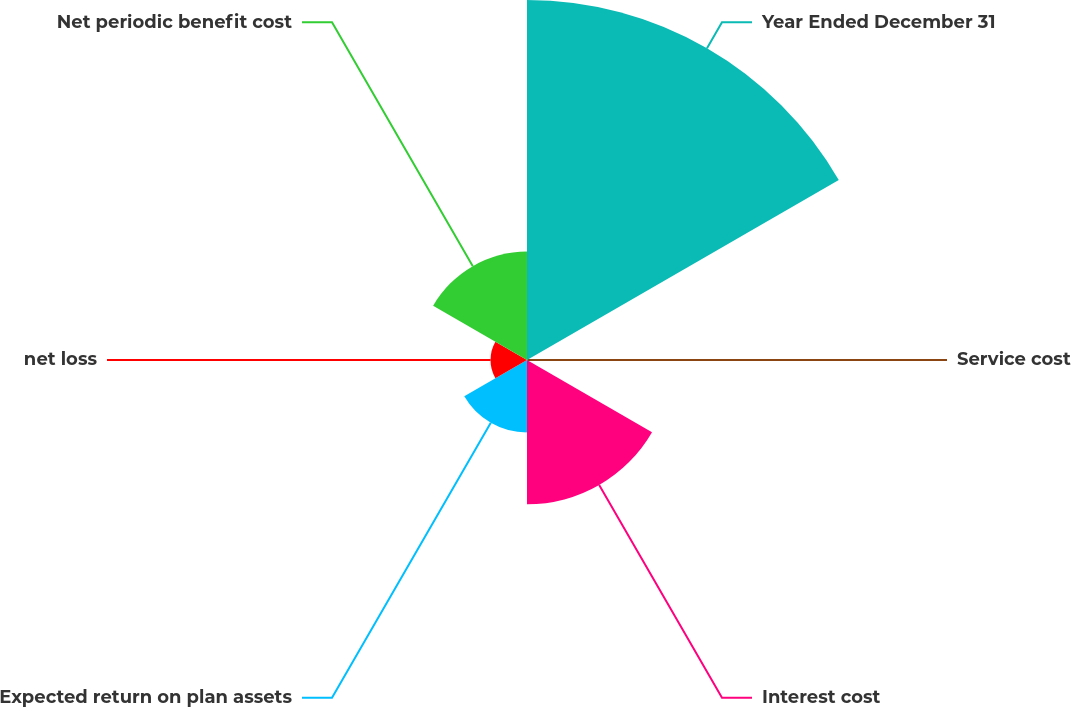Convert chart. <chart><loc_0><loc_0><loc_500><loc_500><pie_chart><fcel>Year Ended December 31<fcel>Service cost<fcel>Interest cost<fcel>Expected return on plan assets<fcel>net loss<fcel>Net periodic benefit cost<nl><fcel>49.85%<fcel>0.07%<fcel>19.99%<fcel>10.03%<fcel>5.05%<fcel>15.01%<nl></chart> 